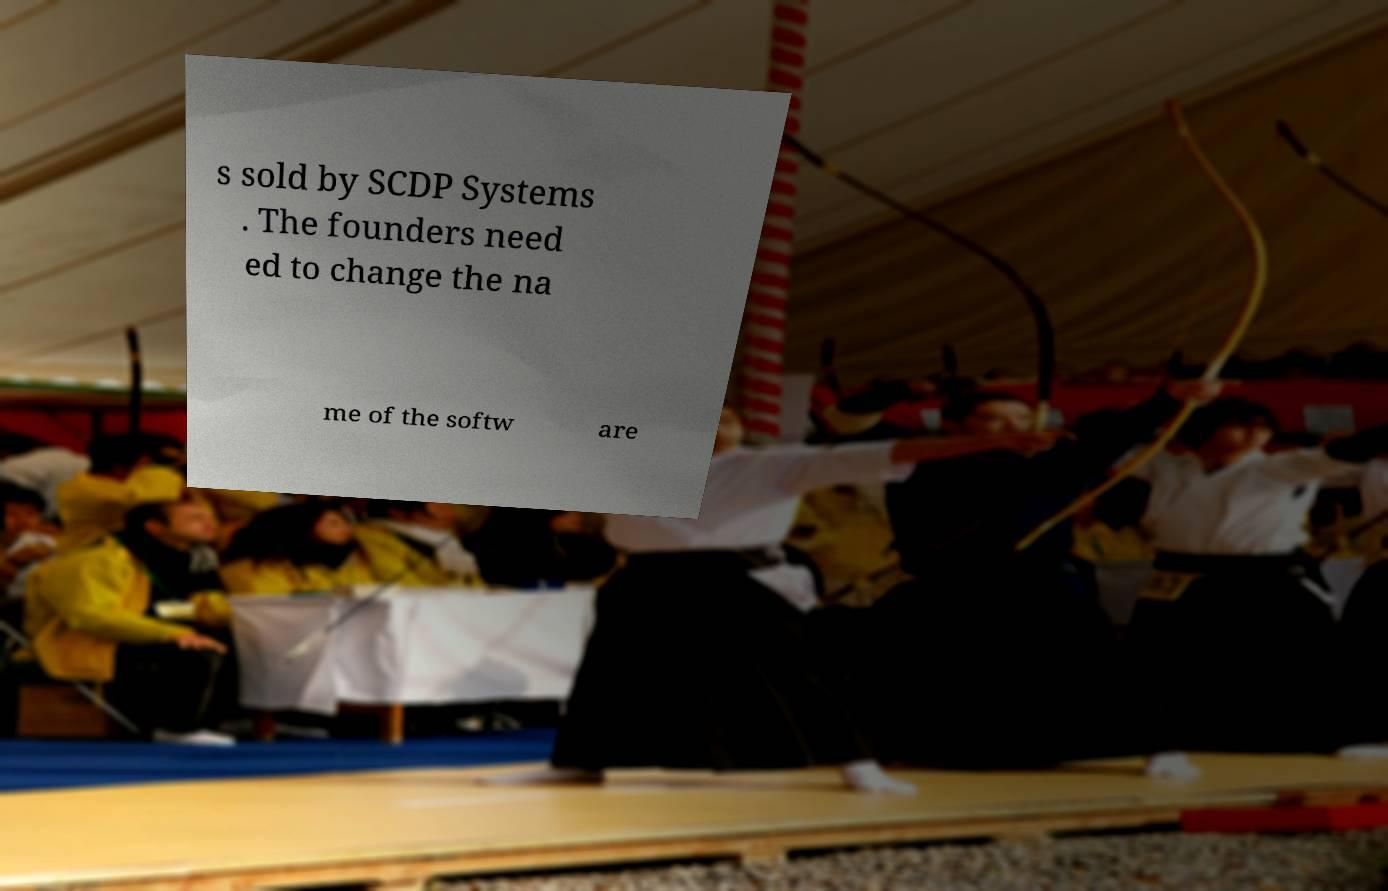Please read and relay the text visible in this image. What does it say? s sold by SCDP Systems . The founders need ed to change the na me of the softw are 